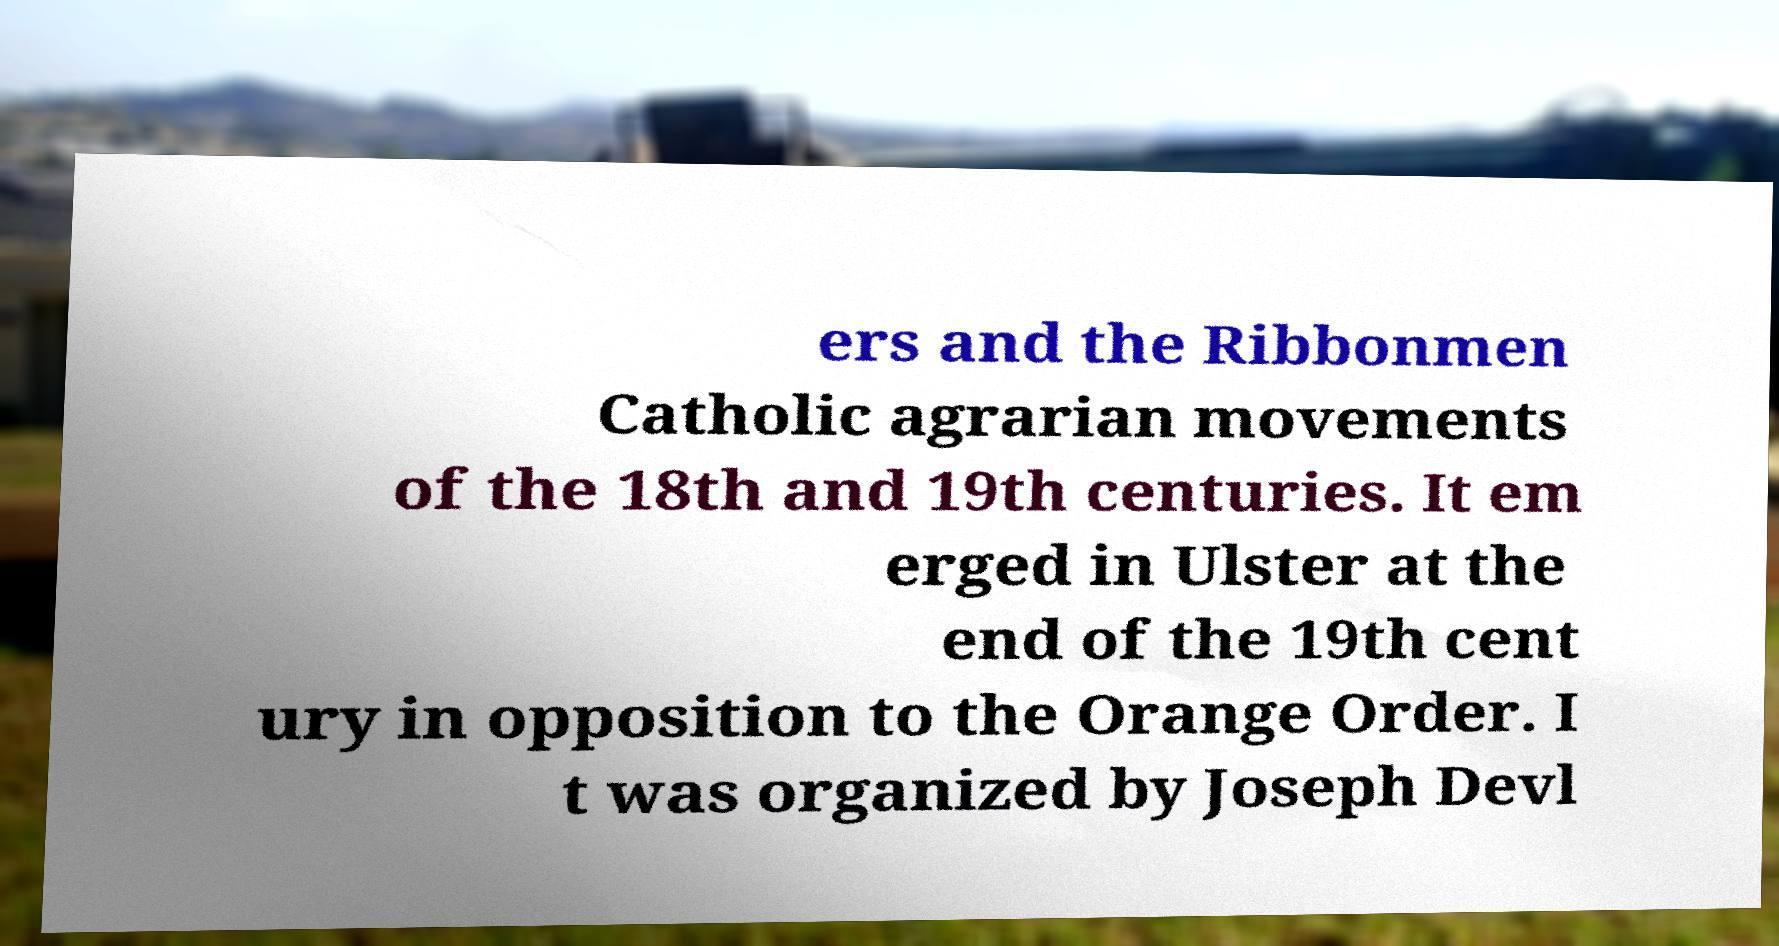Please identify and transcribe the text found in this image. ers and the Ribbonmen Catholic agrarian movements of the 18th and 19th centuries. It em erged in Ulster at the end of the 19th cent ury in opposition to the Orange Order. I t was organized by Joseph Devl 